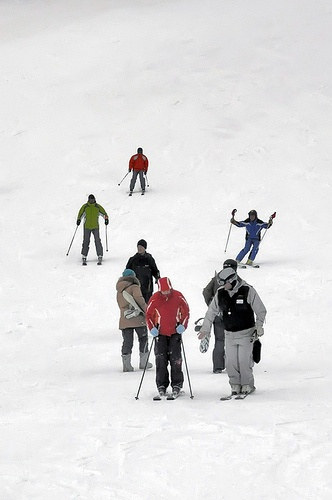Describe the objects in this image and their specific colors. I can see people in lightgray, gray, and black tones, people in lightgray, black, brown, maroon, and gray tones, people in lightgray, gray, black, and darkgray tones, people in lightgray, darkgreen, gray, white, and black tones, and people in lightgray, black, gray, and darkgray tones in this image. 